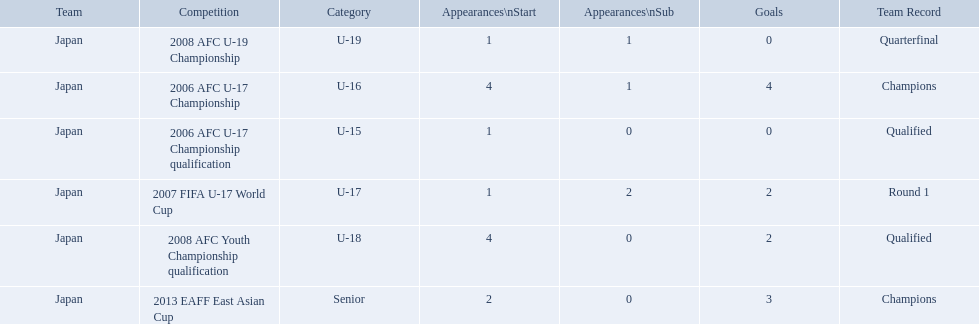What was the team record in 2006? Round 1. What competition did this belong too? 2006 AFC U-17 Championship. 